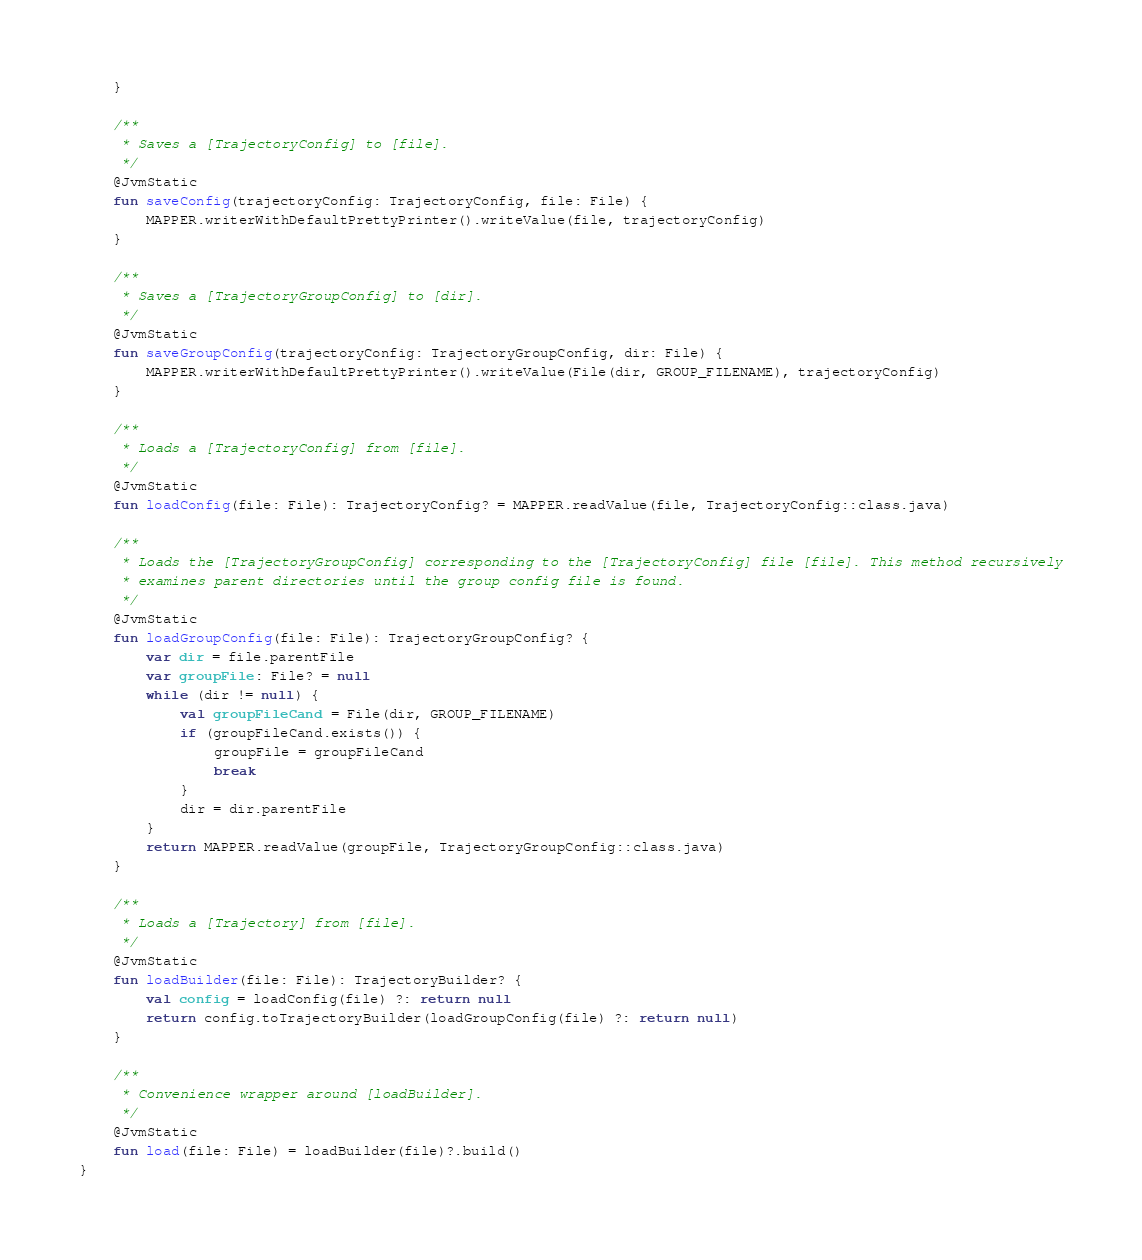Convert code to text. <code><loc_0><loc_0><loc_500><loc_500><_Kotlin_>    }

    /**
     * Saves a [TrajectoryConfig] to [file].
     */
    @JvmStatic
    fun saveConfig(trajectoryConfig: TrajectoryConfig, file: File) {
        MAPPER.writerWithDefaultPrettyPrinter().writeValue(file, trajectoryConfig)
    }

    /**
     * Saves a [TrajectoryGroupConfig] to [dir].
     */
    @JvmStatic
    fun saveGroupConfig(trajectoryConfig: TrajectoryGroupConfig, dir: File) {
        MAPPER.writerWithDefaultPrettyPrinter().writeValue(File(dir, GROUP_FILENAME), trajectoryConfig)
    }

    /**
     * Loads a [TrajectoryConfig] from [file].
     */
    @JvmStatic
    fun loadConfig(file: File): TrajectoryConfig? = MAPPER.readValue(file, TrajectoryConfig::class.java)

    /**
     * Loads the [TrajectoryGroupConfig] corresponding to the [TrajectoryConfig] file [file]. This method recursively
     * examines parent directories until the group config file is found.
     */
    @JvmStatic
    fun loadGroupConfig(file: File): TrajectoryGroupConfig? {
        var dir = file.parentFile
        var groupFile: File? = null
        while (dir != null) {
            val groupFileCand = File(dir, GROUP_FILENAME)
            if (groupFileCand.exists()) {
                groupFile = groupFileCand
                break
            }
            dir = dir.parentFile
        }
        return MAPPER.readValue(groupFile, TrajectoryGroupConfig::class.java)
    }

    /**
     * Loads a [Trajectory] from [file].
     */
    @JvmStatic
    fun loadBuilder(file: File): TrajectoryBuilder? {
        val config = loadConfig(file) ?: return null
        return config.toTrajectoryBuilder(loadGroupConfig(file) ?: return null)
    }

    /**
     * Convenience wrapper around [loadBuilder].
     */
    @JvmStatic
    fun load(file: File) = loadBuilder(file)?.build()
}
</code> 